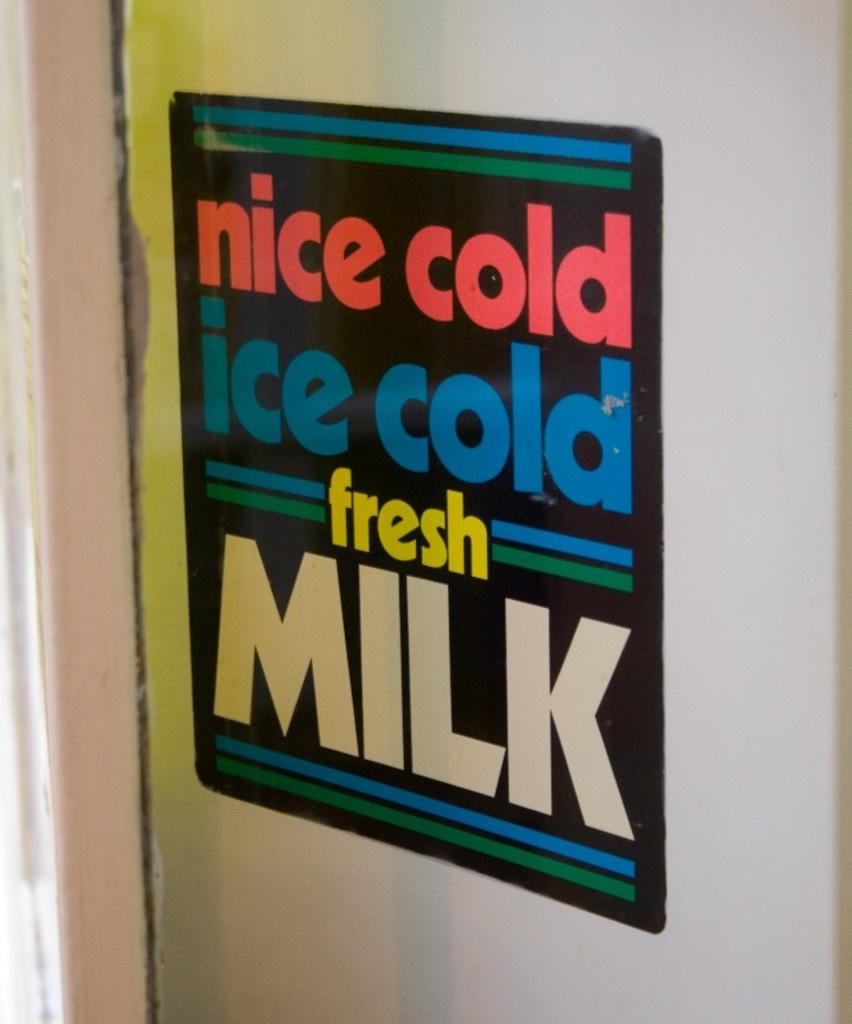<image>
Create a compact narrative representing the image presented. A colorful sign reads "nice cold ice cold fresh milk". 